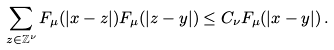<formula> <loc_0><loc_0><loc_500><loc_500>\sum _ { z \in \mathbb { Z } ^ { \nu } } F _ { \mu } ( | x - z | ) F _ { \mu } ( | z - y | ) \leq C _ { \nu } F _ { \mu } ( | x - y | ) \, .</formula> 